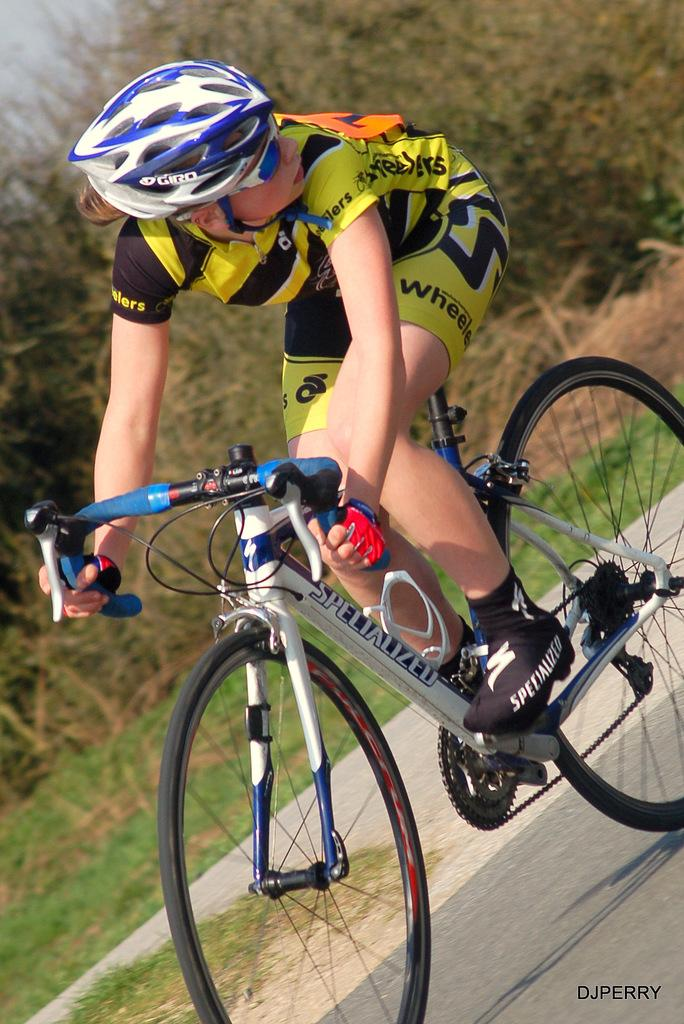What is the person doing in the image? The person is riding a bicycle on a road. What is the person holding while riding the bicycle? The person is holding a handle. What safety gear is the person wearing? The person is wearing a helmet. What color is the person's shirt in the image? The person is wearing a yellow color shirt. What can be seen in the background of the image? There are trees and the sky visible in the background. What type of appliance is the person using to ride the bicycle in the image? There is no appliance involved in riding the bicycle in the image; it is a regular bicycle. Can you tell me how many doors are visible in the image? There are no doors visible in the image; it features a person riding a bicycle on a road with a background of trees and the sky. 